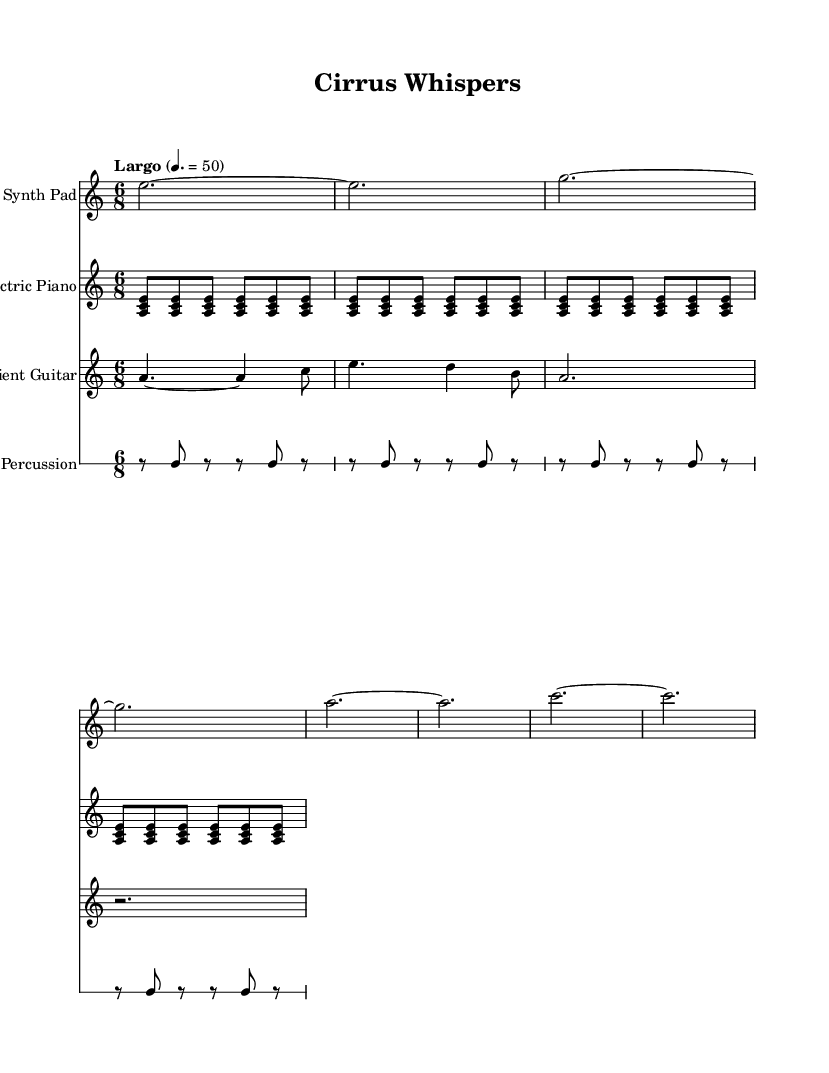What is the key signature of this music? The key signature is indicated as "a", which refers to A minor. Since A minor is the relative minor of C major, it has no sharps or flats.
Answer: A minor What is the time signature of this music? The time signature is displayed as "6/8" at the beginning of the score, indicating that there are six eighth notes in each measure, typically creating a compound meter feel.
Answer: 6/8 What is the tempo marking for this piece? The tempo marking is "Largo" with a BPM of 50, indicating a slow tempo. "Largo" is a term used in music that generally denotes a slow pace.
Answer: Largo, 50 How many measures does the synthesizer pad have before the next instrument enters? The synthesizer pad has 8 measures before any other instruments, as it plays consistently for that duration before a different part is introduced.
Answer: 8 Which instrument plays the first chords in the piece? The Electric Piano plays the first chords in the piece, starting off with a repeated pattern that forms the harmonic basis of the composition.
Answer: Electric Piano What pattern do the percussion instruments follow? The percussion plays a repeating pattern of rests and a single note, specifically alternating with a note on "b" and resting in between, reflecting a simple rhythmic structure.
Answer: Alternating rests and "b" How does the ambient guitar contribute to the overall atmosphere of the music? The ambient guitar uses prolonged notes and varying rhythms, helping to create a lush, atmospheric sound that complements the electronic elements and mirrors the fluidity of cloud formations.
Answer: Lush atmosphere 